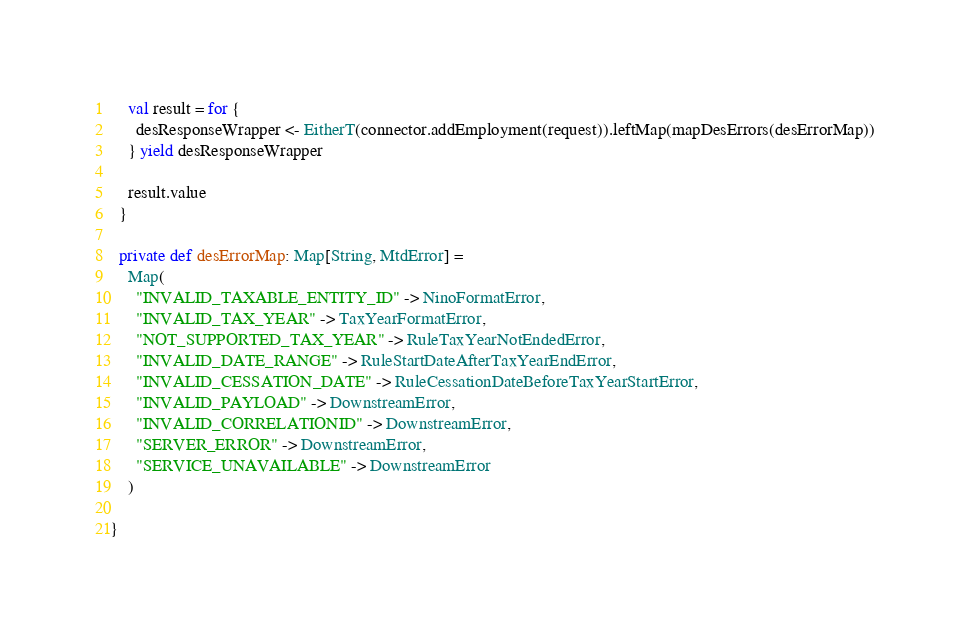Convert code to text. <code><loc_0><loc_0><loc_500><loc_500><_Scala_>
    val result = for {
      desResponseWrapper <- EitherT(connector.addEmployment(request)).leftMap(mapDesErrors(desErrorMap))
    } yield desResponseWrapper

    result.value
  }

  private def desErrorMap: Map[String, MtdError] =
    Map(
      "INVALID_TAXABLE_ENTITY_ID" -> NinoFormatError,
      "INVALID_TAX_YEAR" -> TaxYearFormatError,
      "NOT_SUPPORTED_TAX_YEAR" -> RuleTaxYearNotEndedError,
      "INVALID_DATE_RANGE" -> RuleStartDateAfterTaxYearEndError,
      "INVALID_CESSATION_DATE" -> RuleCessationDateBeforeTaxYearStartError,
      "INVALID_PAYLOAD" -> DownstreamError,
      "INVALID_CORRELATIONID" -> DownstreamError,
      "SERVER_ERROR" -> DownstreamError,
      "SERVICE_UNAVAILABLE" -> DownstreamError
    )

}</code> 